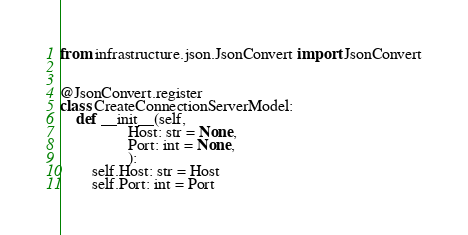<code> <loc_0><loc_0><loc_500><loc_500><_Python_>from infrastructure.json.JsonConvert import JsonConvert


@JsonConvert.register
class CreateConnectionServerModel:
    def __init__(self,
                 Host: str = None,
                 Port: int = None,
                 ):
        self.Host: str = Host
        self.Port: int = Port
</code> 